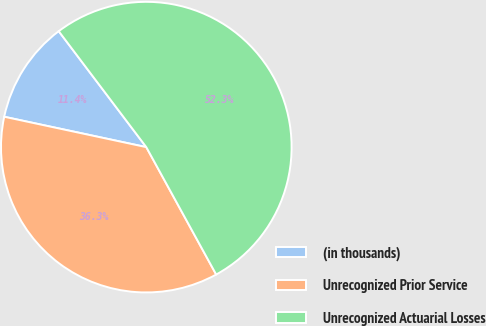Convert chart to OTSL. <chart><loc_0><loc_0><loc_500><loc_500><pie_chart><fcel>(in thousands)<fcel>Unrecognized Prior Service<fcel>Unrecognized Actuarial Losses<nl><fcel>11.35%<fcel>36.34%<fcel>52.31%<nl></chart> 